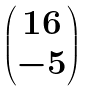<formula> <loc_0><loc_0><loc_500><loc_500>\begin{pmatrix} 1 6 \\ - 5 \end{pmatrix}</formula> 